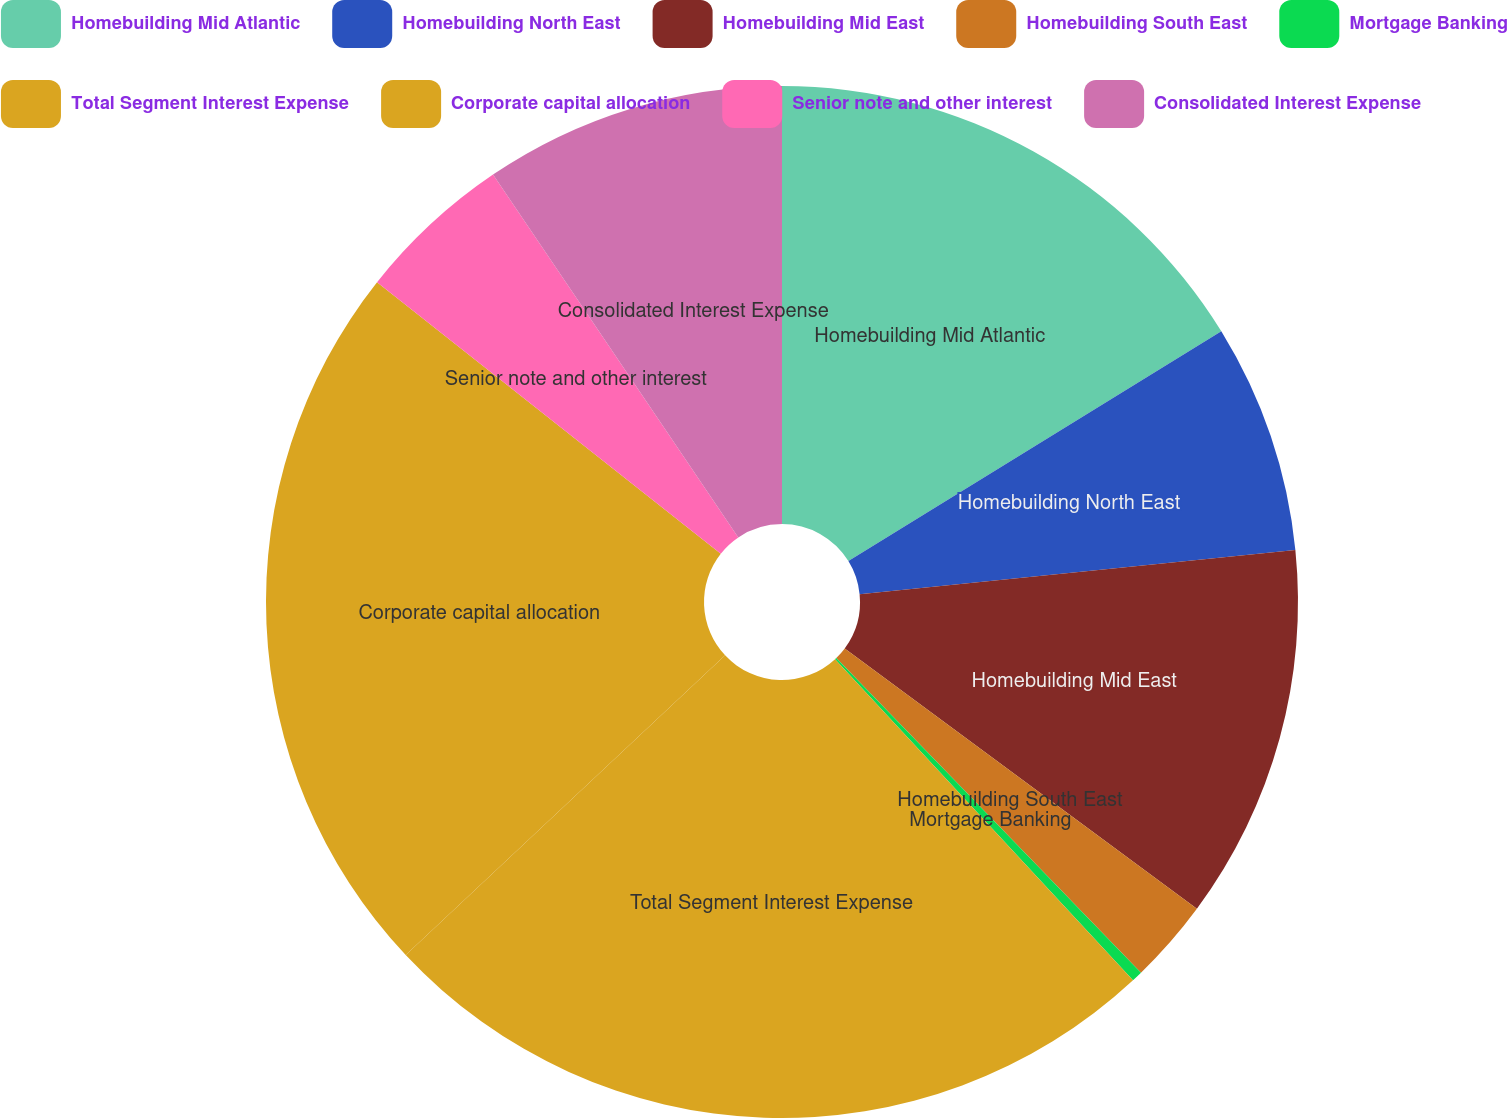Convert chart to OTSL. <chart><loc_0><loc_0><loc_500><loc_500><pie_chart><fcel>Homebuilding Mid Atlantic<fcel>Homebuilding North East<fcel>Homebuilding Mid East<fcel>Homebuilding South East<fcel>Mortgage Banking<fcel>Total Segment Interest Expense<fcel>Corporate capital allocation<fcel>Senior note and other interest<fcel>Consolidated Interest Expense<nl><fcel>16.21%<fcel>7.18%<fcel>11.74%<fcel>2.62%<fcel>0.34%<fcel>24.91%<fcel>22.63%<fcel>4.9%<fcel>9.46%<nl></chart> 